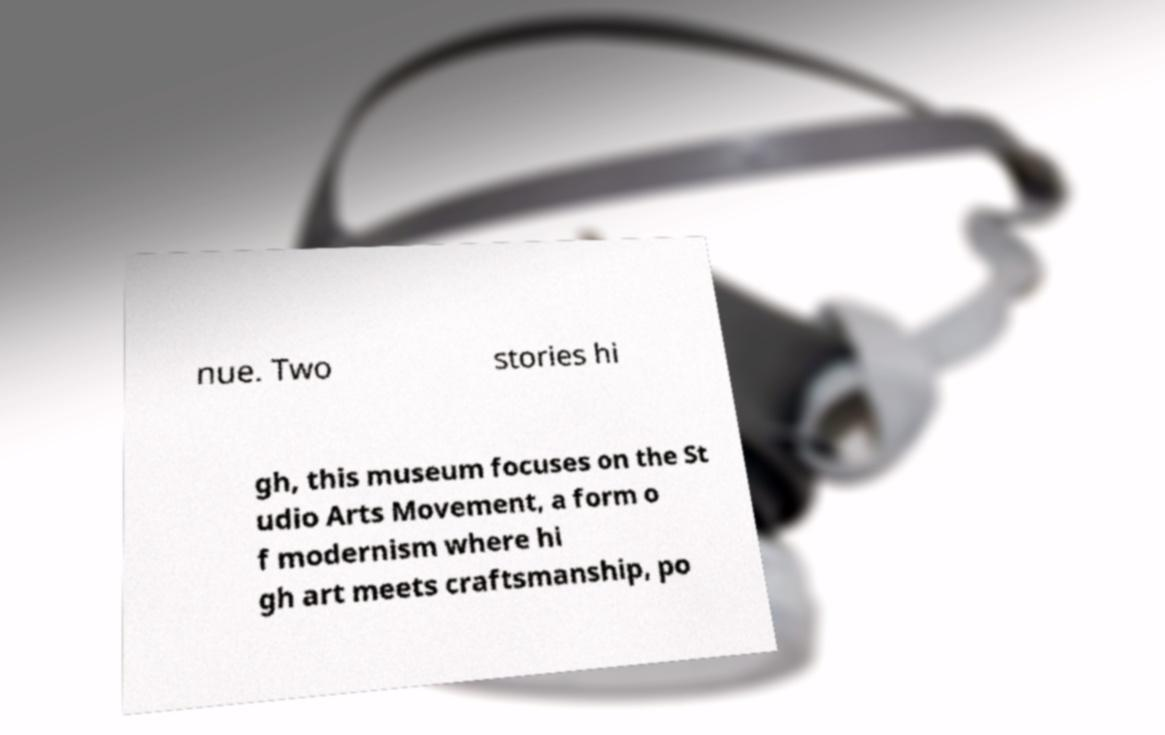Please identify and transcribe the text found in this image. nue. Two stories hi gh, this museum focuses on the St udio Arts Movement, a form o f modernism where hi gh art meets craftsmanship, po 